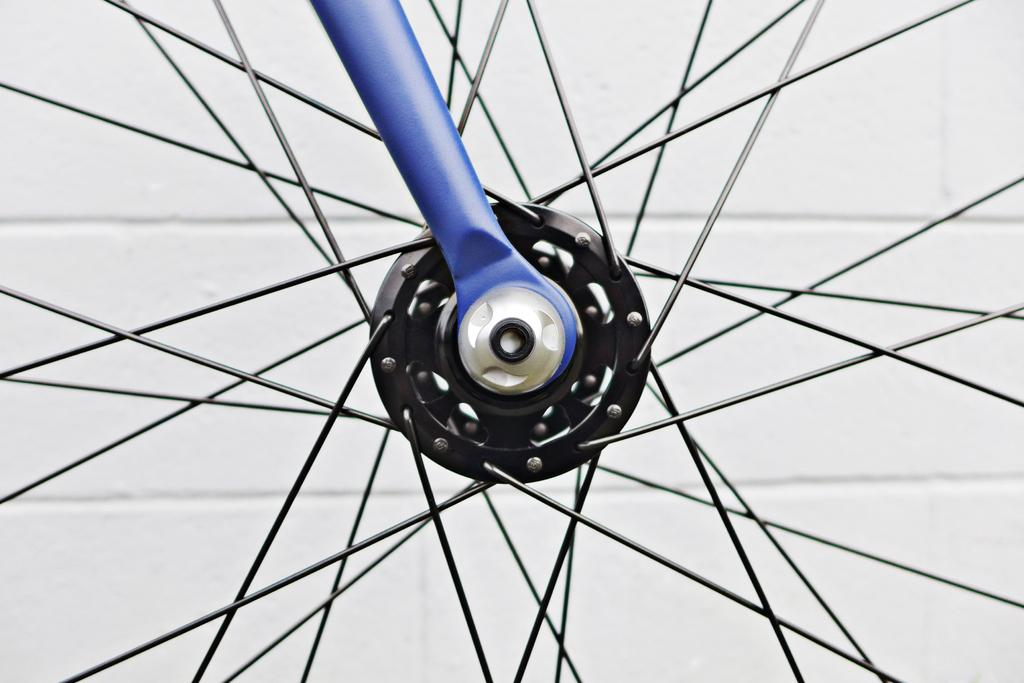What is the main object in the image? There is a wheel in the image. Can you describe the wheel in more detail? The wheel is truncated. What else can be seen in the image besides the wheel? There is a rod in the image. What is visible in the background of the image? There is a wall visible in the background of the image. What type of soda is being ordered by the person in the image? There is no person present in the image, and therefore no soda order can be observed. 